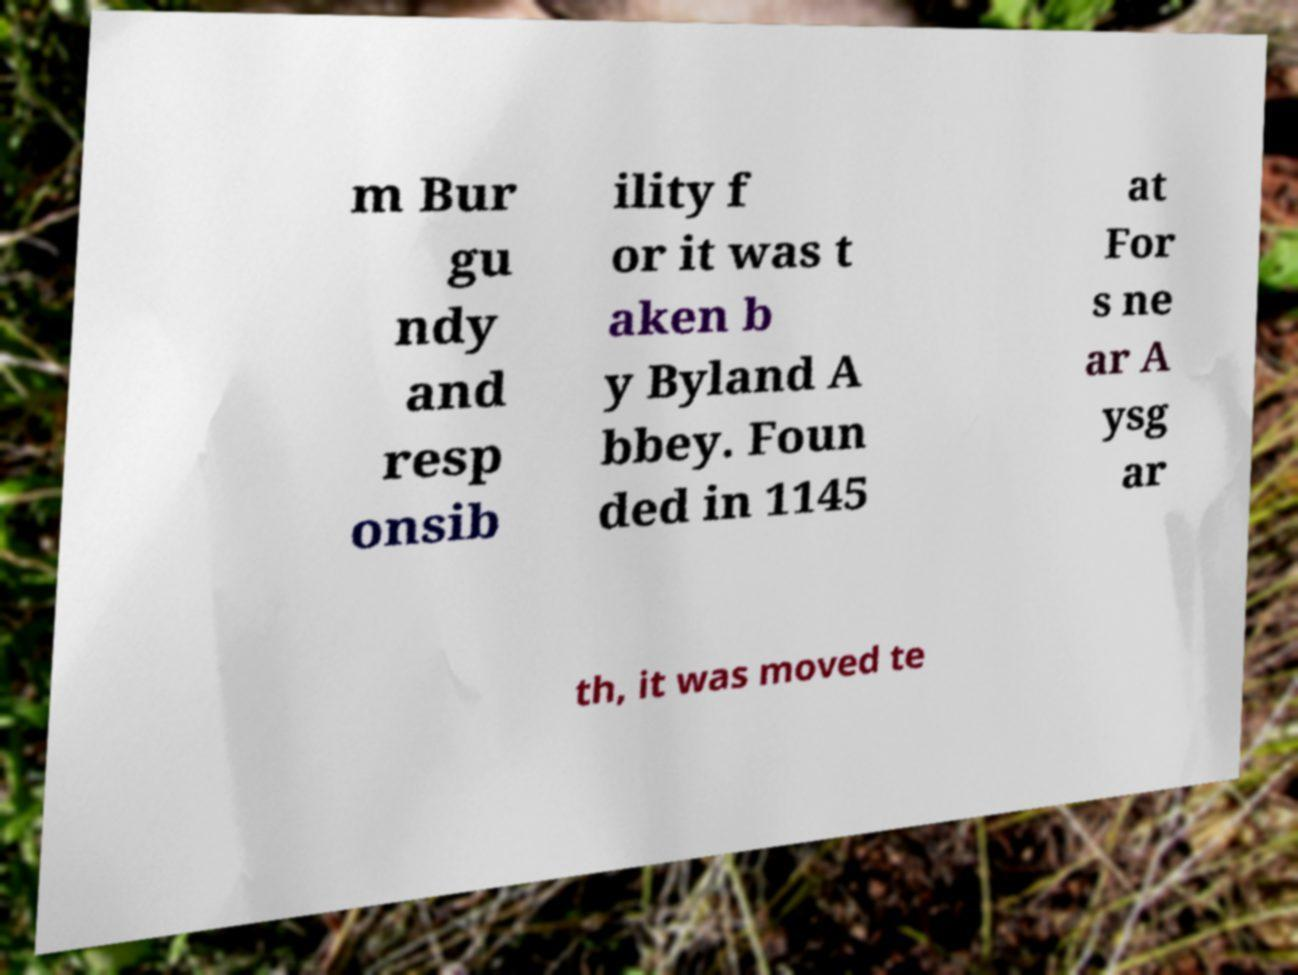There's text embedded in this image that I need extracted. Can you transcribe it verbatim? m Bur gu ndy and resp onsib ility f or it was t aken b y Byland A bbey. Foun ded in 1145 at For s ne ar A ysg ar th, it was moved te 